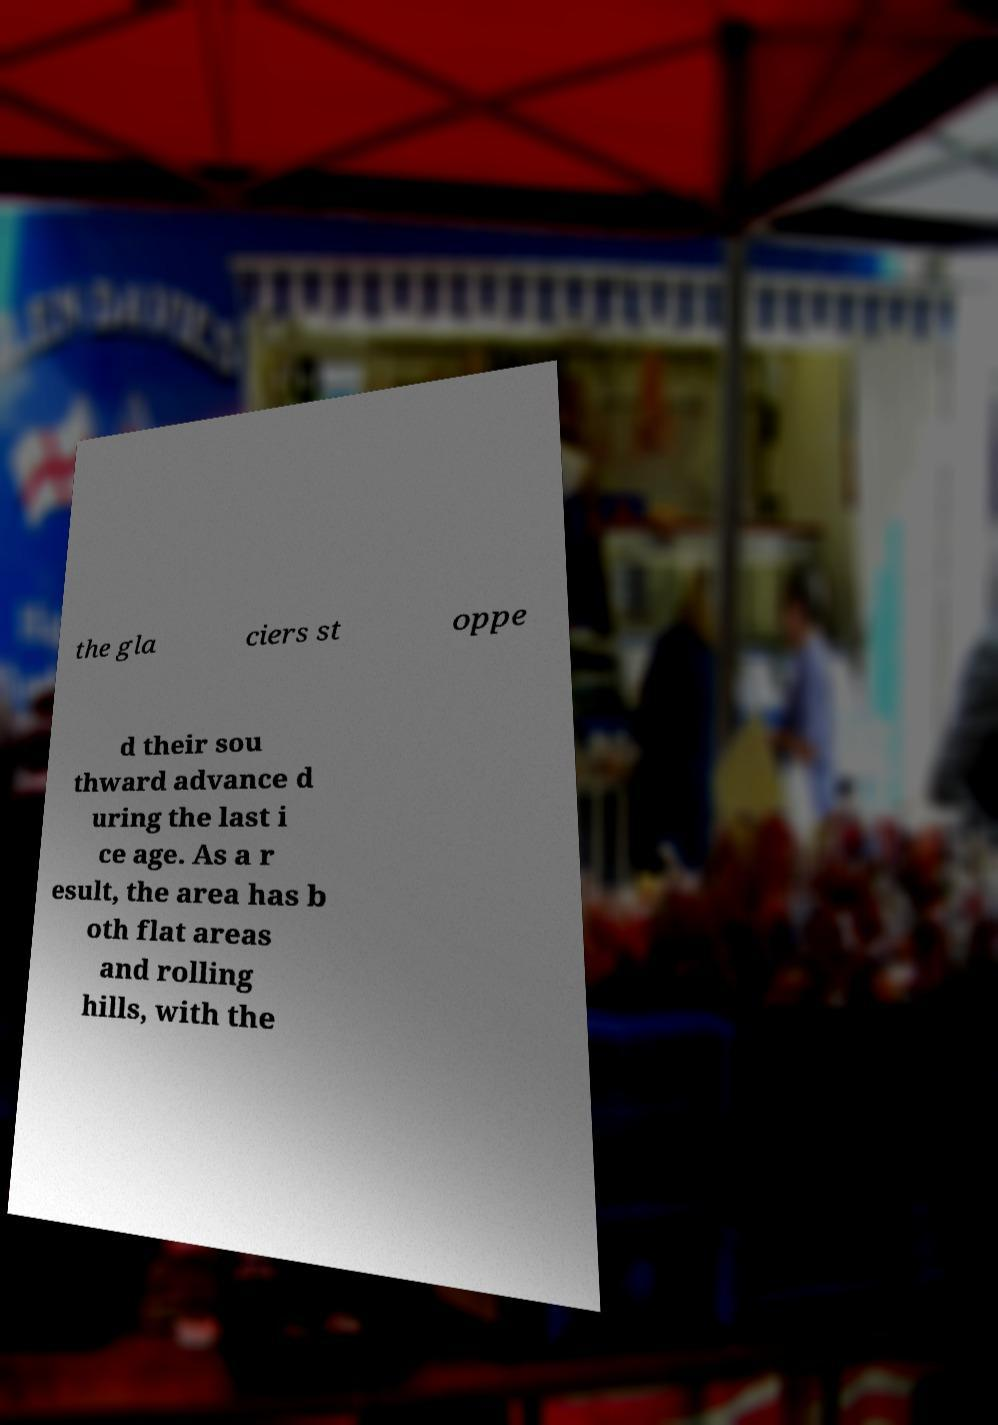Please identify and transcribe the text found in this image. the gla ciers st oppe d their sou thward advance d uring the last i ce age. As a r esult, the area has b oth flat areas and rolling hills, with the 